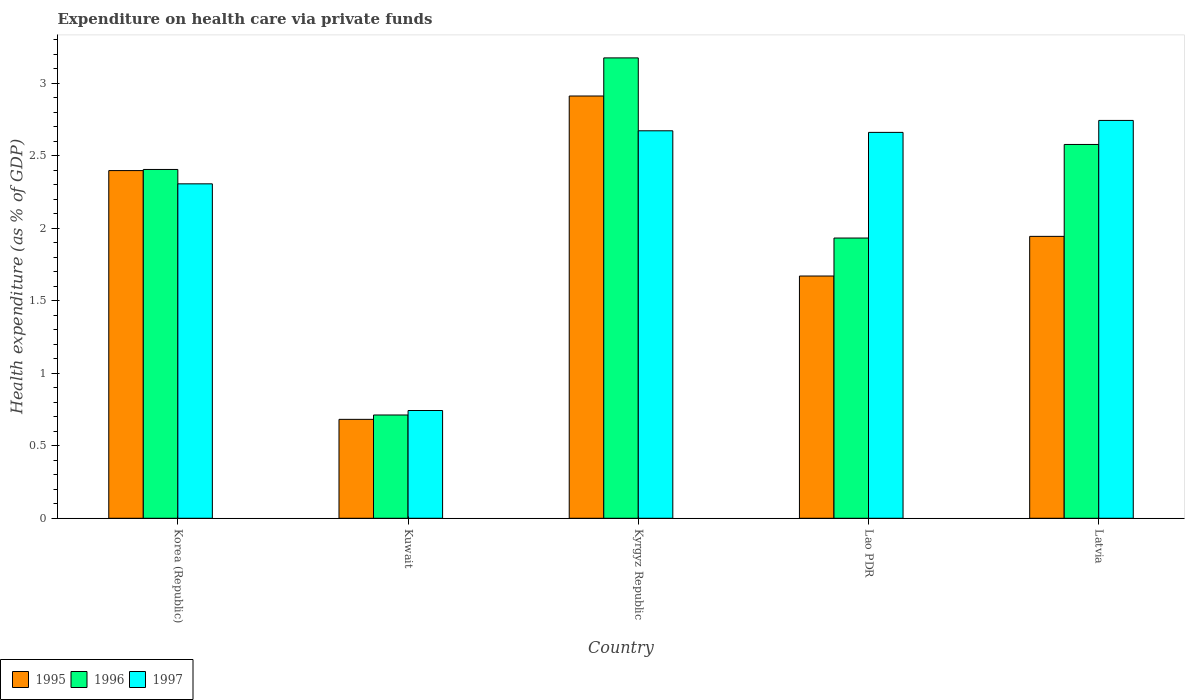How many different coloured bars are there?
Ensure brevity in your answer.  3. Are the number of bars on each tick of the X-axis equal?
Give a very brief answer. Yes. How many bars are there on the 5th tick from the right?
Give a very brief answer. 3. What is the label of the 4th group of bars from the left?
Make the answer very short. Lao PDR. In how many cases, is the number of bars for a given country not equal to the number of legend labels?
Keep it short and to the point. 0. What is the expenditure made on health care in 1996 in Kuwait?
Offer a terse response. 0.71. Across all countries, what is the maximum expenditure made on health care in 1996?
Ensure brevity in your answer.  3.17. Across all countries, what is the minimum expenditure made on health care in 1995?
Your answer should be compact. 0.68. In which country was the expenditure made on health care in 1997 maximum?
Ensure brevity in your answer.  Latvia. In which country was the expenditure made on health care in 1996 minimum?
Your response must be concise. Kuwait. What is the total expenditure made on health care in 1995 in the graph?
Offer a very short reply. 9.61. What is the difference between the expenditure made on health care in 1997 in Lao PDR and that in Latvia?
Give a very brief answer. -0.08. What is the difference between the expenditure made on health care in 1995 in Korea (Republic) and the expenditure made on health care in 1996 in Kuwait?
Keep it short and to the point. 1.69. What is the average expenditure made on health care in 1996 per country?
Your answer should be very brief. 2.16. What is the difference between the expenditure made on health care of/in 1995 and expenditure made on health care of/in 1996 in Kuwait?
Your response must be concise. -0.03. What is the ratio of the expenditure made on health care in 1997 in Kyrgyz Republic to that in Lao PDR?
Your answer should be very brief. 1. Is the difference between the expenditure made on health care in 1995 in Korea (Republic) and Latvia greater than the difference between the expenditure made on health care in 1996 in Korea (Republic) and Latvia?
Offer a terse response. Yes. What is the difference between the highest and the second highest expenditure made on health care in 1995?
Give a very brief answer. -0.97. What is the difference between the highest and the lowest expenditure made on health care in 1996?
Make the answer very short. 2.46. Is the sum of the expenditure made on health care in 1997 in Kyrgyz Republic and Latvia greater than the maximum expenditure made on health care in 1996 across all countries?
Your response must be concise. Yes. How many countries are there in the graph?
Make the answer very short. 5. What is the difference between two consecutive major ticks on the Y-axis?
Your answer should be compact. 0.5. Are the values on the major ticks of Y-axis written in scientific E-notation?
Ensure brevity in your answer.  No. Where does the legend appear in the graph?
Make the answer very short. Bottom left. How are the legend labels stacked?
Make the answer very short. Horizontal. What is the title of the graph?
Provide a succinct answer. Expenditure on health care via private funds. Does "1970" appear as one of the legend labels in the graph?
Your response must be concise. No. What is the label or title of the Y-axis?
Your response must be concise. Health expenditure (as % of GDP). What is the Health expenditure (as % of GDP) of 1995 in Korea (Republic)?
Your response must be concise. 2.4. What is the Health expenditure (as % of GDP) of 1996 in Korea (Republic)?
Offer a terse response. 2.41. What is the Health expenditure (as % of GDP) of 1997 in Korea (Republic)?
Offer a terse response. 2.31. What is the Health expenditure (as % of GDP) of 1995 in Kuwait?
Keep it short and to the point. 0.68. What is the Health expenditure (as % of GDP) of 1996 in Kuwait?
Offer a very short reply. 0.71. What is the Health expenditure (as % of GDP) of 1997 in Kuwait?
Ensure brevity in your answer.  0.74. What is the Health expenditure (as % of GDP) of 1995 in Kyrgyz Republic?
Your answer should be compact. 2.91. What is the Health expenditure (as % of GDP) in 1996 in Kyrgyz Republic?
Your response must be concise. 3.17. What is the Health expenditure (as % of GDP) of 1997 in Kyrgyz Republic?
Provide a succinct answer. 2.67. What is the Health expenditure (as % of GDP) in 1995 in Lao PDR?
Give a very brief answer. 1.67. What is the Health expenditure (as % of GDP) of 1996 in Lao PDR?
Your response must be concise. 1.93. What is the Health expenditure (as % of GDP) in 1997 in Lao PDR?
Your response must be concise. 2.66. What is the Health expenditure (as % of GDP) in 1995 in Latvia?
Your response must be concise. 1.94. What is the Health expenditure (as % of GDP) in 1996 in Latvia?
Keep it short and to the point. 2.58. What is the Health expenditure (as % of GDP) in 1997 in Latvia?
Your response must be concise. 2.74. Across all countries, what is the maximum Health expenditure (as % of GDP) in 1995?
Offer a very short reply. 2.91. Across all countries, what is the maximum Health expenditure (as % of GDP) in 1996?
Your answer should be compact. 3.17. Across all countries, what is the maximum Health expenditure (as % of GDP) in 1997?
Your response must be concise. 2.74. Across all countries, what is the minimum Health expenditure (as % of GDP) in 1995?
Provide a succinct answer. 0.68. Across all countries, what is the minimum Health expenditure (as % of GDP) in 1996?
Ensure brevity in your answer.  0.71. Across all countries, what is the minimum Health expenditure (as % of GDP) in 1997?
Offer a very short reply. 0.74. What is the total Health expenditure (as % of GDP) in 1995 in the graph?
Your response must be concise. 9.61. What is the total Health expenditure (as % of GDP) of 1996 in the graph?
Your response must be concise. 10.8. What is the total Health expenditure (as % of GDP) in 1997 in the graph?
Offer a terse response. 11.13. What is the difference between the Health expenditure (as % of GDP) of 1995 in Korea (Republic) and that in Kuwait?
Give a very brief answer. 1.72. What is the difference between the Health expenditure (as % of GDP) in 1996 in Korea (Republic) and that in Kuwait?
Your answer should be very brief. 1.69. What is the difference between the Health expenditure (as % of GDP) in 1997 in Korea (Republic) and that in Kuwait?
Ensure brevity in your answer.  1.56. What is the difference between the Health expenditure (as % of GDP) in 1995 in Korea (Republic) and that in Kyrgyz Republic?
Your answer should be compact. -0.51. What is the difference between the Health expenditure (as % of GDP) of 1996 in Korea (Republic) and that in Kyrgyz Republic?
Offer a terse response. -0.77. What is the difference between the Health expenditure (as % of GDP) of 1997 in Korea (Republic) and that in Kyrgyz Republic?
Provide a succinct answer. -0.37. What is the difference between the Health expenditure (as % of GDP) of 1995 in Korea (Republic) and that in Lao PDR?
Give a very brief answer. 0.73. What is the difference between the Health expenditure (as % of GDP) in 1996 in Korea (Republic) and that in Lao PDR?
Keep it short and to the point. 0.47. What is the difference between the Health expenditure (as % of GDP) of 1997 in Korea (Republic) and that in Lao PDR?
Give a very brief answer. -0.35. What is the difference between the Health expenditure (as % of GDP) of 1995 in Korea (Republic) and that in Latvia?
Your response must be concise. 0.45. What is the difference between the Health expenditure (as % of GDP) of 1996 in Korea (Republic) and that in Latvia?
Give a very brief answer. -0.17. What is the difference between the Health expenditure (as % of GDP) of 1997 in Korea (Republic) and that in Latvia?
Your response must be concise. -0.44. What is the difference between the Health expenditure (as % of GDP) in 1995 in Kuwait and that in Kyrgyz Republic?
Ensure brevity in your answer.  -2.23. What is the difference between the Health expenditure (as % of GDP) of 1996 in Kuwait and that in Kyrgyz Republic?
Ensure brevity in your answer.  -2.46. What is the difference between the Health expenditure (as % of GDP) in 1997 in Kuwait and that in Kyrgyz Republic?
Your response must be concise. -1.93. What is the difference between the Health expenditure (as % of GDP) in 1995 in Kuwait and that in Lao PDR?
Provide a succinct answer. -0.99. What is the difference between the Health expenditure (as % of GDP) in 1996 in Kuwait and that in Lao PDR?
Your answer should be very brief. -1.22. What is the difference between the Health expenditure (as % of GDP) in 1997 in Kuwait and that in Lao PDR?
Your response must be concise. -1.92. What is the difference between the Health expenditure (as % of GDP) of 1995 in Kuwait and that in Latvia?
Keep it short and to the point. -1.26. What is the difference between the Health expenditure (as % of GDP) of 1996 in Kuwait and that in Latvia?
Your response must be concise. -1.87. What is the difference between the Health expenditure (as % of GDP) of 1997 in Kuwait and that in Latvia?
Offer a very short reply. -2. What is the difference between the Health expenditure (as % of GDP) of 1995 in Kyrgyz Republic and that in Lao PDR?
Ensure brevity in your answer.  1.24. What is the difference between the Health expenditure (as % of GDP) in 1996 in Kyrgyz Republic and that in Lao PDR?
Make the answer very short. 1.24. What is the difference between the Health expenditure (as % of GDP) in 1997 in Kyrgyz Republic and that in Lao PDR?
Your answer should be very brief. 0.01. What is the difference between the Health expenditure (as % of GDP) in 1995 in Kyrgyz Republic and that in Latvia?
Make the answer very short. 0.97. What is the difference between the Health expenditure (as % of GDP) of 1996 in Kyrgyz Republic and that in Latvia?
Offer a very short reply. 0.6. What is the difference between the Health expenditure (as % of GDP) in 1997 in Kyrgyz Republic and that in Latvia?
Your answer should be compact. -0.07. What is the difference between the Health expenditure (as % of GDP) in 1995 in Lao PDR and that in Latvia?
Offer a very short reply. -0.27. What is the difference between the Health expenditure (as % of GDP) in 1996 in Lao PDR and that in Latvia?
Make the answer very short. -0.65. What is the difference between the Health expenditure (as % of GDP) of 1997 in Lao PDR and that in Latvia?
Offer a very short reply. -0.08. What is the difference between the Health expenditure (as % of GDP) of 1995 in Korea (Republic) and the Health expenditure (as % of GDP) of 1996 in Kuwait?
Provide a short and direct response. 1.69. What is the difference between the Health expenditure (as % of GDP) of 1995 in Korea (Republic) and the Health expenditure (as % of GDP) of 1997 in Kuwait?
Your response must be concise. 1.65. What is the difference between the Health expenditure (as % of GDP) of 1996 in Korea (Republic) and the Health expenditure (as % of GDP) of 1997 in Kuwait?
Provide a short and direct response. 1.66. What is the difference between the Health expenditure (as % of GDP) in 1995 in Korea (Republic) and the Health expenditure (as % of GDP) in 1996 in Kyrgyz Republic?
Give a very brief answer. -0.78. What is the difference between the Health expenditure (as % of GDP) in 1995 in Korea (Republic) and the Health expenditure (as % of GDP) in 1997 in Kyrgyz Republic?
Ensure brevity in your answer.  -0.27. What is the difference between the Health expenditure (as % of GDP) of 1996 in Korea (Republic) and the Health expenditure (as % of GDP) of 1997 in Kyrgyz Republic?
Ensure brevity in your answer.  -0.27. What is the difference between the Health expenditure (as % of GDP) in 1995 in Korea (Republic) and the Health expenditure (as % of GDP) in 1996 in Lao PDR?
Offer a terse response. 0.47. What is the difference between the Health expenditure (as % of GDP) in 1995 in Korea (Republic) and the Health expenditure (as % of GDP) in 1997 in Lao PDR?
Your answer should be very brief. -0.26. What is the difference between the Health expenditure (as % of GDP) in 1996 in Korea (Republic) and the Health expenditure (as % of GDP) in 1997 in Lao PDR?
Provide a succinct answer. -0.26. What is the difference between the Health expenditure (as % of GDP) of 1995 in Korea (Republic) and the Health expenditure (as % of GDP) of 1996 in Latvia?
Keep it short and to the point. -0.18. What is the difference between the Health expenditure (as % of GDP) of 1995 in Korea (Republic) and the Health expenditure (as % of GDP) of 1997 in Latvia?
Your response must be concise. -0.35. What is the difference between the Health expenditure (as % of GDP) of 1996 in Korea (Republic) and the Health expenditure (as % of GDP) of 1997 in Latvia?
Provide a succinct answer. -0.34. What is the difference between the Health expenditure (as % of GDP) in 1995 in Kuwait and the Health expenditure (as % of GDP) in 1996 in Kyrgyz Republic?
Make the answer very short. -2.49. What is the difference between the Health expenditure (as % of GDP) of 1995 in Kuwait and the Health expenditure (as % of GDP) of 1997 in Kyrgyz Republic?
Give a very brief answer. -1.99. What is the difference between the Health expenditure (as % of GDP) of 1996 in Kuwait and the Health expenditure (as % of GDP) of 1997 in Kyrgyz Republic?
Provide a short and direct response. -1.96. What is the difference between the Health expenditure (as % of GDP) in 1995 in Kuwait and the Health expenditure (as % of GDP) in 1996 in Lao PDR?
Provide a succinct answer. -1.25. What is the difference between the Health expenditure (as % of GDP) in 1995 in Kuwait and the Health expenditure (as % of GDP) in 1997 in Lao PDR?
Keep it short and to the point. -1.98. What is the difference between the Health expenditure (as % of GDP) of 1996 in Kuwait and the Health expenditure (as % of GDP) of 1997 in Lao PDR?
Give a very brief answer. -1.95. What is the difference between the Health expenditure (as % of GDP) in 1995 in Kuwait and the Health expenditure (as % of GDP) in 1996 in Latvia?
Keep it short and to the point. -1.9. What is the difference between the Health expenditure (as % of GDP) in 1995 in Kuwait and the Health expenditure (as % of GDP) in 1997 in Latvia?
Make the answer very short. -2.06. What is the difference between the Health expenditure (as % of GDP) in 1996 in Kuwait and the Health expenditure (as % of GDP) in 1997 in Latvia?
Provide a succinct answer. -2.03. What is the difference between the Health expenditure (as % of GDP) of 1995 in Kyrgyz Republic and the Health expenditure (as % of GDP) of 1996 in Lao PDR?
Provide a short and direct response. 0.98. What is the difference between the Health expenditure (as % of GDP) of 1995 in Kyrgyz Republic and the Health expenditure (as % of GDP) of 1997 in Lao PDR?
Your response must be concise. 0.25. What is the difference between the Health expenditure (as % of GDP) in 1996 in Kyrgyz Republic and the Health expenditure (as % of GDP) in 1997 in Lao PDR?
Provide a succinct answer. 0.51. What is the difference between the Health expenditure (as % of GDP) of 1995 in Kyrgyz Republic and the Health expenditure (as % of GDP) of 1996 in Latvia?
Give a very brief answer. 0.33. What is the difference between the Health expenditure (as % of GDP) of 1995 in Kyrgyz Republic and the Health expenditure (as % of GDP) of 1997 in Latvia?
Give a very brief answer. 0.17. What is the difference between the Health expenditure (as % of GDP) of 1996 in Kyrgyz Republic and the Health expenditure (as % of GDP) of 1997 in Latvia?
Provide a succinct answer. 0.43. What is the difference between the Health expenditure (as % of GDP) of 1995 in Lao PDR and the Health expenditure (as % of GDP) of 1996 in Latvia?
Offer a very short reply. -0.91. What is the difference between the Health expenditure (as % of GDP) in 1995 in Lao PDR and the Health expenditure (as % of GDP) in 1997 in Latvia?
Make the answer very short. -1.07. What is the difference between the Health expenditure (as % of GDP) in 1996 in Lao PDR and the Health expenditure (as % of GDP) in 1997 in Latvia?
Ensure brevity in your answer.  -0.81. What is the average Health expenditure (as % of GDP) in 1995 per country?
Provide a short and direct response. 1.92. What is the average Health expenditure (as % of GDP) in 1996 per country?
Provide a short and direct response. 2.16. What is the average Health expenditure (as % of GDP) of 1997 per country?
Give a very brief answer. 2.23. What is the difference between the Health expenditure (as % of GDP) of 1995 and Health expenditure (as % of GDP) of 1996 in Korea (Republic)?
Your answer should be compact. -0.01. What is the difference between the Health expenditure (as % of GDP) of 1995 and Health expenditure (as % of GDP) of 1997 in Korea (Republic)?
Provide a succinct answer. 0.09. What is the difference between the Health expenditure (as % of GDP) in 1996 and Health expenditure (as % of GDP) in 1997 in Korea (Republic)?
Give a very brief answer. 0.1. What is the difference between the Health expenditure (as % of GDP) in 1995 and Health expenditure (as % of GDP) in 1996 in Kuwait?
Your answer should be compact. -0.03. What is the difference between the Health expenditure (as % of GDP) of 1995 and Health expenditure (as % of GDP) of 1997 in Kuwait?
Provide a succinct answer. -0.06. What is the difference between the Health expenditure (as % of GDP) of 1996 and Health expenditure (as % of GDP) of 1997 in Kuwait?
Keep it short and to the point. -0.03. What is the difference between the Health expenditure (as % of GDP) of 1995 and Health expenditure (as % of GDP) of 1996 in Kyrgyz Republic?
Your response must be concise. -0.26. What is the difference between the Health expenditure (as % of GDP) of 1995 and Health expenditure (as % of GDP) of 1997 in Kyrgyz Republic?
Provide a succinct answer. 0.24. What is the difference between the Health expenditure (as % of GDP) of 1996 and Health expenditure (as % of GDP) of 1997 in Kyrgyz Republic?
Offer a terse response. 0.5. What is the difference between the Health expenditure (as % of GDP) in 1995 and Health expenditure (as % of GDP) in 1996 in Lao PDR?
Your answer should be compact. -0.26. What is the difference between the Health expenditure (as % of GDP) in 1995 and Health expenditure (as % of GDP) in 1997 in Lao PDR?
Offer a very short reply. -0.99. What is the difference between the Health expenditure (as % of GDP) in 1996 and Health expenditure (as % of GDP) in 1997 in Lao PDR?
Your answer should be compact. -0.73. What is the difference between the Health expenditure (as % of GDP) in 1995 and Health expenditure (as % of GDP) in 1996 in Latvia?
Your answer should be compact. -0.63. What is the difference between the Health expenditure (as % of GDP) of 1995 and Health expenditure (as % of GDP) of 1997 in Latvia?
Ensure brevity in your answer.  -0.8. What is the difference between the Health expenditure (as % of GDP) of 1996 and Health expenditure (as % of GDP) of 1997 in Latvia?
Provide a short and direct response. -0.17. What is the ratio of the Health expenditure (as % of GDP) of 1995 in Korea (Republic) to that in Kuwait?
Make the answer very short. 3.51. What is the ratio of the Health expenditure (as % of GDP) of 1996 in Korea (Republic) to that in Kuwait?
Provide a short and direct response. 3.38. What is the ratio of the Health expenditure (as % of GDP) in 1997 in Korea (Republic) to that in Kuwait?
Keep it short and to the point. 3.1. What is the ratio of the Health expenditure (as % of GDP) in 1995 in Korea (Republic) to that in Kyrgyz Republic?
Give a very brief answer. 0.82. What is the ratio of the Health expenditure (as % of GDP) in 1996 in Korea (Republic) to that in Kyrgyz Republic?
Offer a terse response. 0.76. What is the ratio of the Health expenditure (as % of GDP) in 1997 in Korea (Republic) to that in Kyrgyz Republic?
Your answer should be compact. 0.86. What is the ratio of the Health expenditure (as % of GDP) in 1995 in Korea (Republic) to that in Lao PDR?
Give a very brief answer. 1.44. What is the ratio of the Health expenditure (as % of GDP) of 1996 in Korea (Republic) to that in Lao PDR?
Provide a succinct answer. 1.24. What is the ratio of the Health expenditure (as % of GDP) in 1997 in Korea (Republic) to that in Lao PDR?
Give a very brief answer. 0.87. What is the ratio of the Health expenditure (as % of GDP) of 1995 in Korea (Republic) to that in Latvia?
Give a very brief answer. 1.23. What is the ratio of the Health expenditure (as % of GDP) in 1996 in Korea (Republic) to that in Latvia?
Ensure brevity in your answer.  0.93. What is the ratio of the Health expenditure (as % of GDP) of 1997 in Korea (Republic) to that in Latvia?
Provide a succinct answer. 0.84. What is the ratio of the Health expenditure (as % of GDP) of 1995 in Kuwait to that in Kyrgyz Republic?
Ensure brevity in your answer.  0.23. What is the ratio of the Health expenditure (as % of GDP) of 1996 in Kuwait to that in Kyrgyz Republic?
Your answer should be very brief. 0.22. What is the ratio of the Health expenditure (as % of GDP) of 1997 in Kuwait to that in Kyrgyz Republic?
Offer a terse response. 0.28. What is the ratio of the Health expenditure (as % of GDP) of 1995 in Kuwait to that in Lao PDR?
Ensure brevity in your answer.  0.41. What is the ratio of the Health expenditure (as % of GDP) of 1996 in Kuwait to that in Lao PDR?
Your answer should be compact. 0.37. What is the ratio of the Health expenditure (as % of GDP) in 1997 in Kuwait to that in Lao PDR?
Offer a very short reply. 0.28. What is the ratio of the Health expenditure (as % of GDP) of 1995 in Kuwait to that in Latvia?
Offer a terse response. 0.35. What is the ratio of the Health expenditure (as % of GDP) of 1996 in Kuwait to that in Latvia?
Keep it short and to the point. 0.28. What is the ratio of the Health expenditure (as % of GDP) in 1997 in Kuwait to that in Latvia?
Make the answer very short. 0.27. What is the ratio of the Health expenditure (as % of GDP) of 1995 in Kyrgyz Republic to that in Lao PDR?
Provide a short and direct response. 1.74. What is the ratio of the Health expenditure (as % of GDP) of 1996 in Kyrgyz Republic to that in Lao PDR?
Give a very brief answer. 1.64. What is the ratio of the Health expenditure (as % of GDP) in 1997 in Kyrgyz Republic to that in Lao PDR?
Your answer should be very brief. 1. What is the ratio of the Health expenditure (as % of GDP) of 1995 in Kyrgyz Republic to that in Latvia?
Your answer should be compact. 1.5. What is the ratio of the Health expenditure (as % of GDP) of 1996 in Kyrgyz Republic to that in Latvia?
Offer a terse response. 1.23. What is the ratio of the Health expenditure (as % of GDP) of 1997 in Kyrgyz Republic to that in Latvia?
Your answer should be very brief. 0.97. What is the ratio of the Health expenditure (as % of GDP) in 1995 in Lao PDR to that in Latvia?
Your response must be concise. 0.86. What is the ratio of the Health expenditure (as % of GDP) in 1996 in Lao PDR to that in Latvia?
Make the answer very short. 0.75. What is the ratio of the Health expenditure (as % of GDP) in 1997 in Lao PDR to that in Latvia?
Offer a very short reply. 0.97. What is the difference between the highest and the second highest Health expenditure (as % of GDP) of 1995?
Your answer should be compact. 0.51. What is the difference between the highest and the second highest Health expenditure (as % of GDP) in 1996?
Keep it short and to the point. 0.6. What is the difference between the highest and the second highest Health expenditure (as % of GDP) in 1997?
Your response must be concise. 0.07. What is the difference between the highest and the lowest Health expenditure (as % of GDP) in 1995?
Ensure brevity in your answer.  2.23. What is the difference between the highest and the lowest Health expenditure (as % of GDP) of 1996?
Your answer should be compact. 2.46. What is the difference between the highest and the lowest Health expenditure (as % of GDP) of 1997?
Provide a succinct answer. 2. 